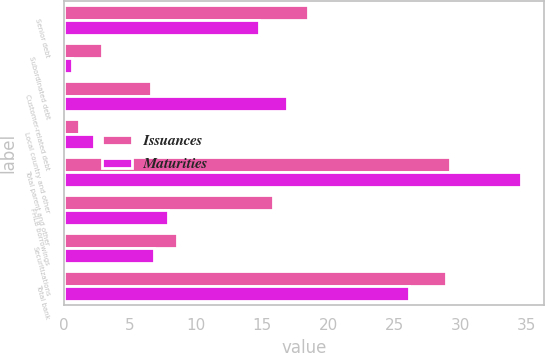Convert chart. <chart><loc_0><loc_0><loc_500><loc_500><stacked_bar_chart><ecel><fcel>Senior debt<fcel>Subordinated debt<fcel>Customer-related debt<fcel>Local country and other<fcel>Total parent and other<fcel>FHLB borrowings<fcel>Securitizations<fcel>Total bank<nl><fcel>Issuances<fcel>18.5<fcel>2.9<fcel>6.6<fcel>1.2<fcel>29.2<fcel>15.8<fcel>8.6<fcel>28.9<nl><fcel>Maturities<fcel>14.8<fcel>0.6<fcel>16.9<fcel>2.3<fcel>34.6<fcel>7.9<fcel>6.8<fcel>26.1<nl></chart> 